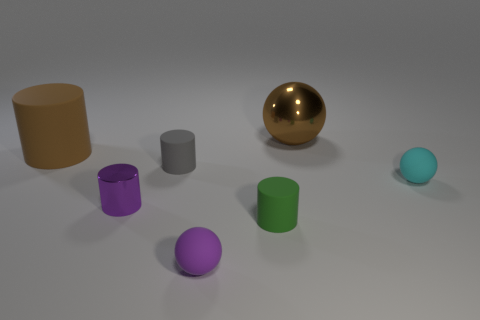What number of other objects are the same color as the metallic sphere?
Make the answer very short. 1. Do the small metallic object and the tiny matte sphere in front of the green matte object have the same color?
Ensure brevity in your answer.  Yes. Do the metallic object that is on the left side of the shiny ball and the small rubber ball left of the tiny green cylinder have the same color?
Ensure brevity in your answer.  Yes. What is the size of the thing that is the same color as the big cylinder?
Make the answer very short. Large. What number of big things are rubber balls or red matte cylinders?
Your response must be concise. 0. What number of small blue shiny cylinders are there?
Provide a succinct answer. 0. Is the number of green rubber things that are on the left side of the green matte cylinder the same as the number of gray rubber cylinders behind the small gray rubber thing?
Provide a short and direct response. Yes. There is a tiny purple metal cylinder; are there any rubber things left of it?
Provide a short and direct response. Yes. There is a sphere in front of the tiny cyan ball; what color is it?
Ensure brevity in your answer.  Purple. What is the material of the small sphere that is in front of the ball that is on the right side of the brown ball?
Offer a very short reply. Rubber. 